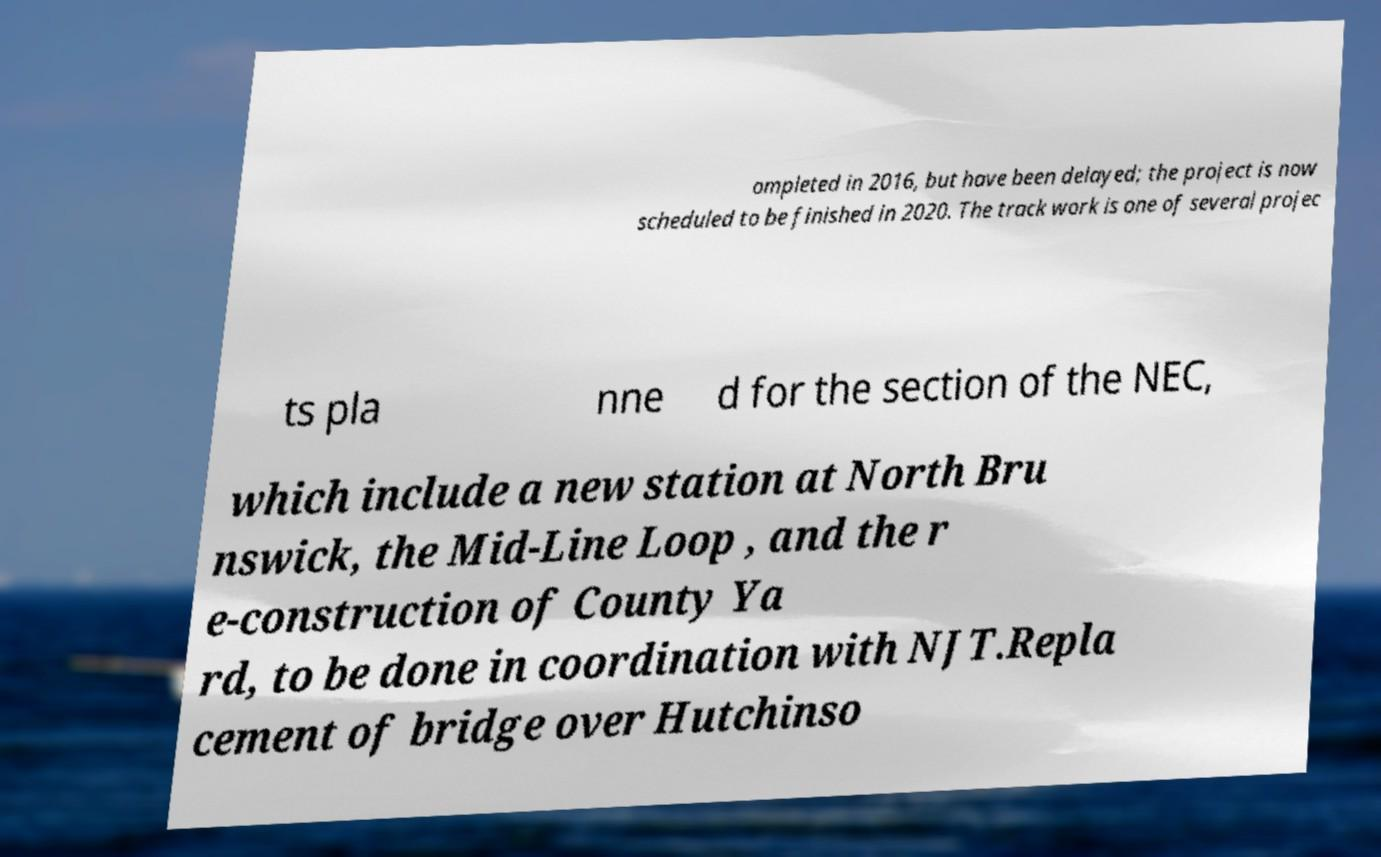Please read and relay the text visible in this image. What does it say? ompleted in 2016, but have been delayed; the project is now scheduled to be finished in 2020. The track work is one of several projec ts pla nne d for the section of the NEC, which include a new station at North Bru nswick, the Mid-Line Loop , and the r e-construction of County Ya rd, to be done in coordination with NJT.Repla cement of bridge over Hutchinso 